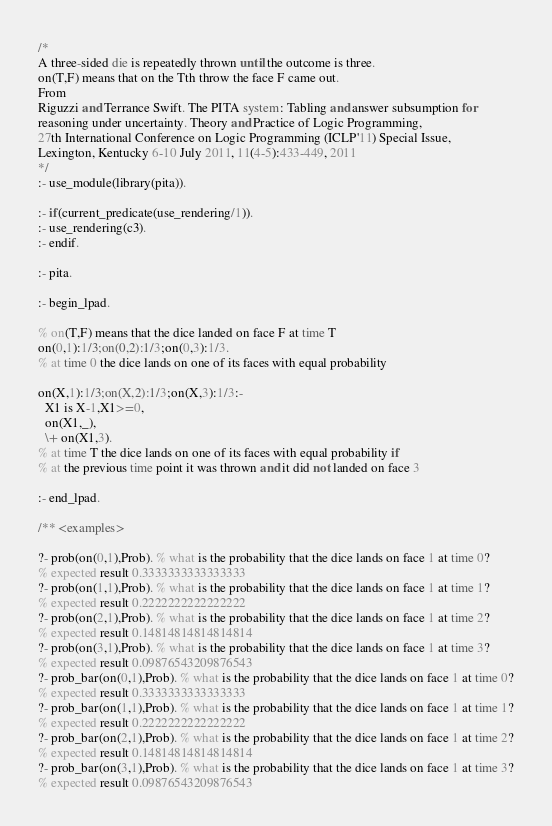<code> <loc_0><loc_0><loc_500><loc_500><_Perl_>/*
A three-sided die is repeatedly thrown until the outcome is three.
on(T,F) means that on the Tth throw the face F came out.
From
Riguzzi and Terrance Swift. The PITA system: Tabling and answer subsumption for 
reasoning under uncertainty. Theory and Practice of Logic Programming, 
27th International Conference on Logic Programming (ICLP'11) Special Issue, 
Lexington, Kentucky 6-10 July 2011, 11(4-5):433-449, 2011
*/
:- use_module(library(pita)).

:- if(current_predicate(use_rendering/1)).
:- use_rendering(c3).
:- endif.

:- pita.

:- begin_lpad.

% on(T,F) means that the dice landed on face F at time T
on(0,1):1/3;on(0,2):1/3;on(0,3):1/3.
% at time 0 the dice lands on one of its faces with equal probability

on(X,1):1/3;on(X,2):1/3;on(X,3):1/3:-
  X1 is X-1,X1>=0,
  on(X1,_),
  \+ on(X1,3).
% at time T the dice lands on one of its faces with equal probability if
% at the previous time point it was thrown and it did not landed on face 3

:- end_lpad.

/** <examples>

?- prob(on(0,1),Prob). % what is the probability that the dice lands on face 1 at time 0?
% expected result 0.3333333333333333
?- prob(on(1,1),Prob). % what is the probability that the dice lands on face 1 at time 1?
% expected result 0.2222222222222222
?- prob(on(2,1),Prob). % what is the probability that the dice lands on face 1 at time 2?
% expected result 0.14814814814814814
?- prob(on(3,1),Prob). % what is the probability that the dice lands on face 1 at time 3?
% expected result 0.09876543209876543
?- prob_bar(on(0,1),Prob). % what is the probability that the dice lands on face 1 at time 0?
% expected result 0.3333333333333333
?- prob_bar(on(1,1),Prob). % what is the probability that the dice lands on face 1 at time 1?
% expected result 0.2222222222222222
?- prob_bar(on(2,1),Prob). % what is the probability that the dice lands on face 1 at time 2?
% expected result 0.14814814814814814
?- prob_bar(on(3,1),Prob). % what is the probability that the dice lands on face 1 at time 3?
% expected result 0.09876543209876543
</code> 